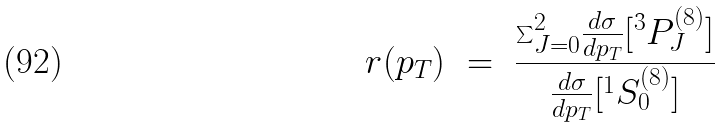<formula> <loc_0><loc_0><loc_500><loc_500>r ( p _ { T } ) \ = \ \frac { { \sum } _ { J = 0 } ^ { 2 } \frac { d { \sigma } } { d p _ { T } } [ ^ { 3 } P _ { J } ^ { ( 8 ) } ] } { \frac { d { \sigma } } { d p _ { T } } [ ^ { 1 } S _ { 0 } ^ { ( 8 ) } ] }</formula> 